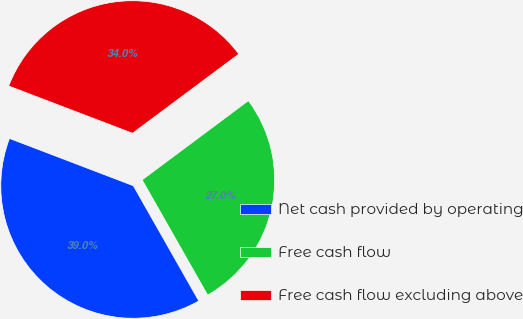Convert chart. <chart><loc_0><loc_0><loc_500><loc_500><pie_chart><fcel>Net cash provided by operating<fcel>Free cash flow<fcel>Free cash flow excluding above<nl><fcel>39.03%<fcel>26.97%<fcel>34.0%<nl></chart> 